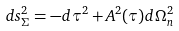<formula> <loc_0><loc_0><loc_500><loc_500>d s _ { \Sigma } ^ { 2 } = - d \tau ^ { 2 } + A ^ { 2 } ( \tau ) d \Omega _ { n } ^ { 2 }</formula> 